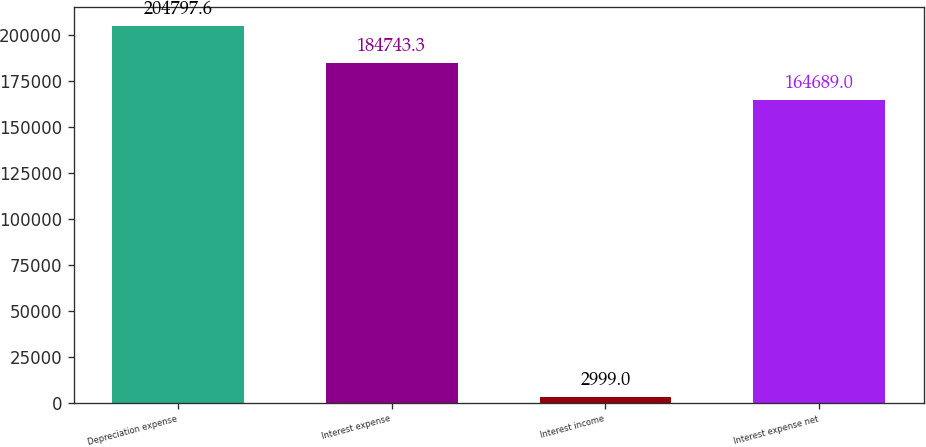<chart> <loc_0><loc_0><loc_500><loc_500><bar_chart><fcel>Depreciation expense<fcel>Interest expense<fcel>Interest income<fcel>Interest expense net<nl><fcel>204798<fcel>184743<fcel>2999<fcel>164689<nl></chart> 